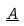Convert formula to latex. <formula><loc_0><loc_0><loc_500><loc_500>\underline { A }</formula> 